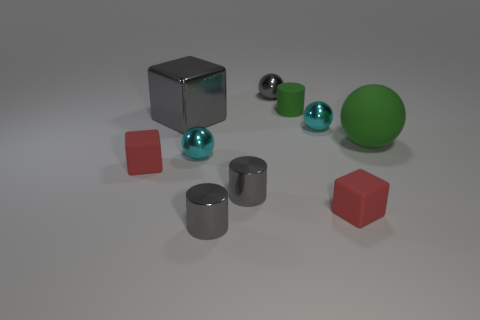There is a block that is behind the small shiny ball to the left of the metallic object that is behind the large metal object; what is it made of?
Provide a succinct answer. Metal. What number of balls are the same color as the shiny cube?
Offer a terse response. 1. There is a green object that is made of the same material as the tiny green cylinder; what size is it?
Give a very brief answer. Large. What number of green things are big rubber spheres or big metal spheres?
Offer a very short reply. 1. What number of tiny matte things are right of the tiny red thing that is on the right side of the small green rubber cylinder?
Your answer should be compact. 0. Is the number of shiny balls that are in front of the green cylinder greater than the number of cubes that are in front of the gray cube?
Keep it short and to the point. No. What is the tiny green cylinder made of?
Offer a very short reply. Rubber. Is there a green sphere of the same size as the shiny block?
Keep it short and to the point. Yes. There is a sphere that is the same size as the gray block; what material is it?
Give a very brief answer. Rubber. How many red rubber things are there?
Offer a very short reply. 2. 